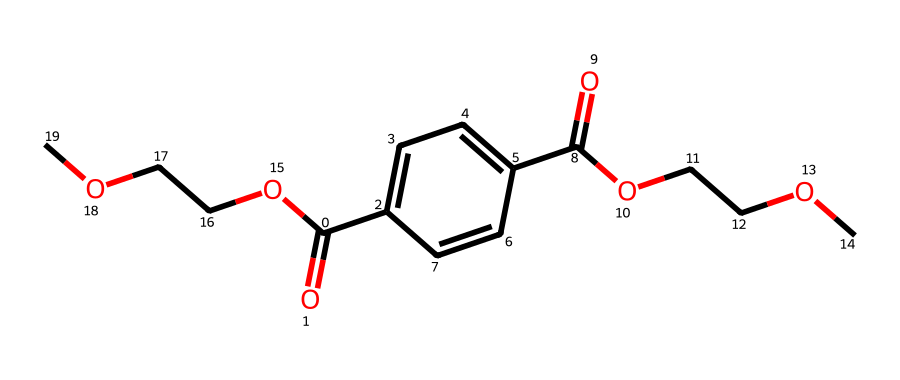What type of polymer is represented by this chemical structure? This chemical structure represents polyethylene terephthalate (PET), a common thermoplastic polymer used in various applications including water bottles.
Answer: polyethylene terephthalate How many carbon atoms are present in this structure? By examining the SMILES representation, we count the carbon atoms, which include those in the aromatic ring and the aliphatic chain. There are a total of 16 carbon atoms.
Answer: 16 Is there any presence of ester functional groups in this chemical? The SMILES representation shows carbonyl (C=O) groups adjacent to oxygen atoms, indicating the presence of ester functional groups, which are characteristic of polyethylene terephthalate.
Answer: yes How many oxygen atoms are in the structure? We can identify the oxygen atoms from the SMILES notation, where the "O" symbols indicate oxygen presence, leading us to count a total of 4 oxygen atoms in the structure.
Answer: 4 What type of bonding is present between the carbon and oxygen in the ester groups? The bonding in the ester functional groups includes a double bond (C=O) and a single bond (C-O), indicating that the carbon atoms are connected to oxygen atoms through these types of bonds.
Answer: covalent What role does this polymer (PET) play in water bottles concerning trauma survivors? PET is widely used in water bottles due to its lightweight, durability, and safety in holding beverages. It provides a reliable and safe packaging option that can support trauma survivors' hydration needs.
Answer: packaging 